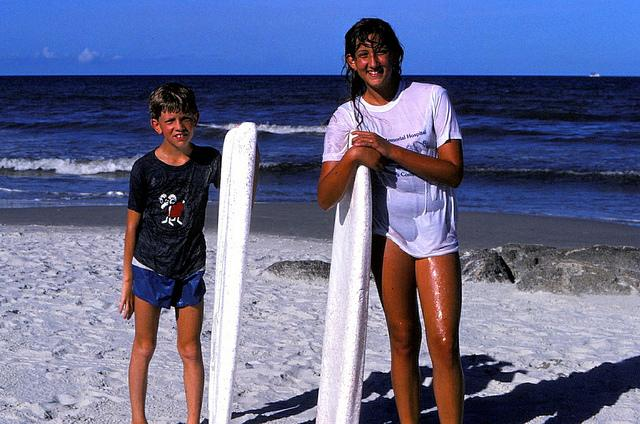How do these people know each other?

Choices:
A) coworkers
B) teammates
C) siblings
D) rivals siblings 